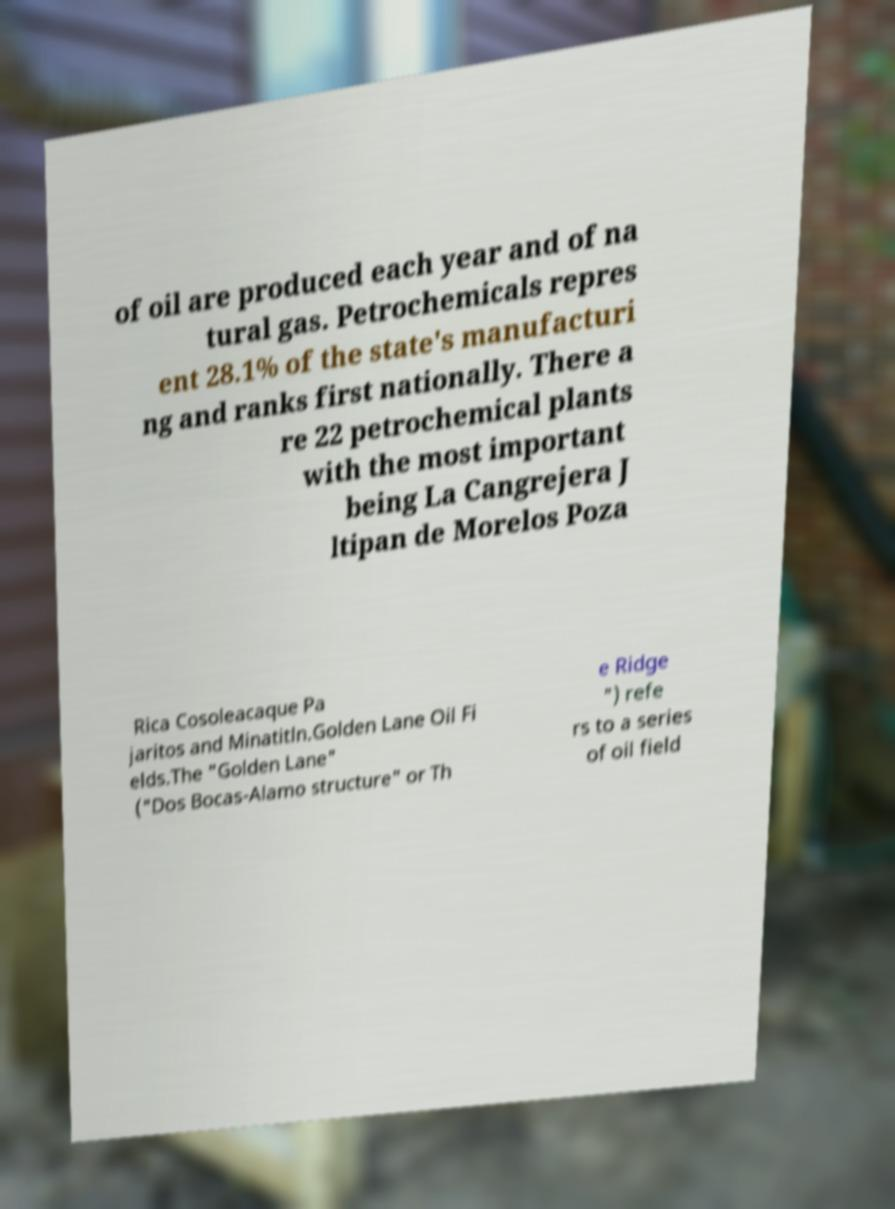There's text embedded in this image that I need extracted. Can you transcribe it verbatim? of oil are produced each year and of na tural gas. Petrochemicals repres ent 28.1% of the state's manufacturi ng and ranks first nationally. There a re 22 petrochemical plants with the most important being La Cangrejera J ltipan de Morelos Poza Rica Cosoleacaque Pa jaritos and Minatitln.Golden Lane Oil Fi elds.The "Golden Lane" ("Dos Bocas-Alamo structure" or Th e Ridge ") refe rs to a series of oil field 